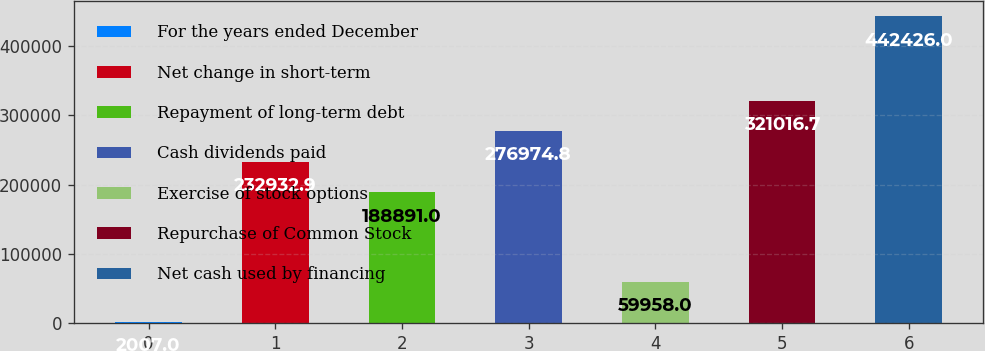Convert chart to OTSL. <chart><loc_0><loc_0><loc_500><loc_500><bar_chart><fcel>For the years ended December<fcel>Net change in short-term<fcel>Repayment of long-term debt<fcel>Cash dividends paid<fcel>Exercise of stock options<fcel>Repurchase of Common Stock<fcel>Net cash used by financing<nl><fcel>2007<fcel>232933<fcel>188891<fcel>276975<fcel>59958<fcel>321017<fcel>442426<nl></chart> 